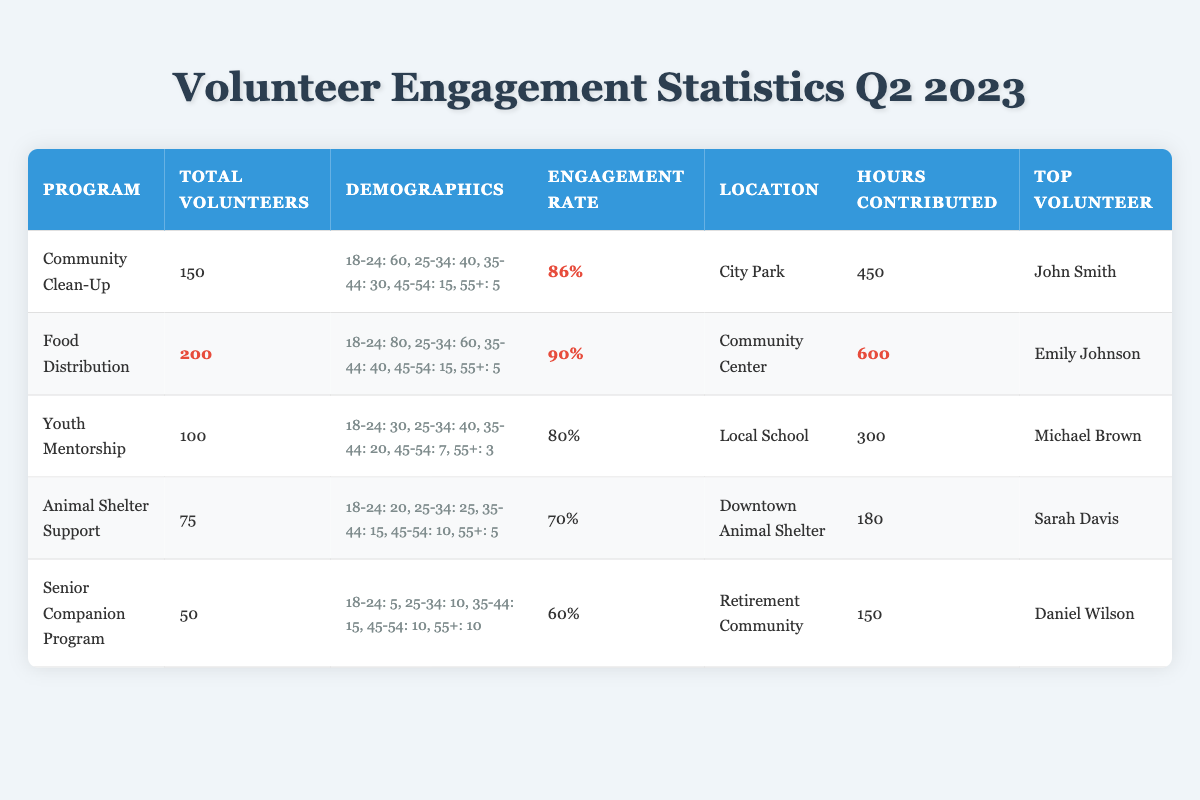What program had the highest number of volunteers? By checking the "Total Volunteers" column, we see that the "Food Distribution" program has the highest total with 200 volunteers.
Answer: Food Distribution Which program had the lowest engagement rate? Looking at the "Engagement Rate" column, the "Senior Companion Program" has the lowest engagement rate at 60%.
Answer: Senior Companion Program What demographic contributed the most volunteers to the "Community Clean-Up" program? Reviewing the demographics for the "Community Clean-Up": Age 18-24 has the highest number (60 volunteers).
Answer: Age 18-24 How many hours were contributed in total across all programs? We can add the "Hours Contributed" for each program: 450 + 600 + 300 + 180 + 150 = 1680 hours in total.
Answer: 1680 What is the average engagement rate across all programs? To find the average, we first convert each engagement rate to decimal: 0.86, 0.90, 0.80, 0.70, and 0.60. Summing them gives 4.86. We divide by 5 (the number of programs): 4.86 / 5 = 0.972, or 97.2%.
Answer: 97.2% Which age group had the least representation in the "Senior Companion Program"? In the "Senior Companion Program", the age group 18-24 had the least representation with only 5 volunteers.
Answer: Age 18-24 Is the "Top Volunteer" for the "Food Distribution" program named Emily Johnson? By looking at the "Top Volunteer" column for "Food Distribution", it is indeed Emily Johnson.
Answer: Yes What’s the difference in hours contributed between "Food Distribution" and "Senior Companion Program"? "Food Distribution" contributed 600 hours and "Senior Companion Program" contributed 150 hours. The difference is 600 - 150 = 450 hours.
Answer: 450 hours How many total volunteers participated in programs aimed at youth? The "Youth Mentorship" program aimed at youth had 100 volunteers. This is the only program in that category, so the total is simply 100.
Answer: 100 What is the percentage of volunteers aged 25-34 for the "Animal Shelter Support" program? There are 25 volunteers aged 25-34 out of a total of 75 volunteers. The percentage is (25/75)*100 = 33.33%.
Answer: 33.33% Which program had a higher engagement rate, "Community Clean-Up" or "Youth Mentorship"? "Community Clean-Up" has an engagement rate of 86%, while "Youth Mentorship" has 80%. Therefore, "Community Clean-Up" has a higher engagement rate.
Answer: Community Clean-Up 